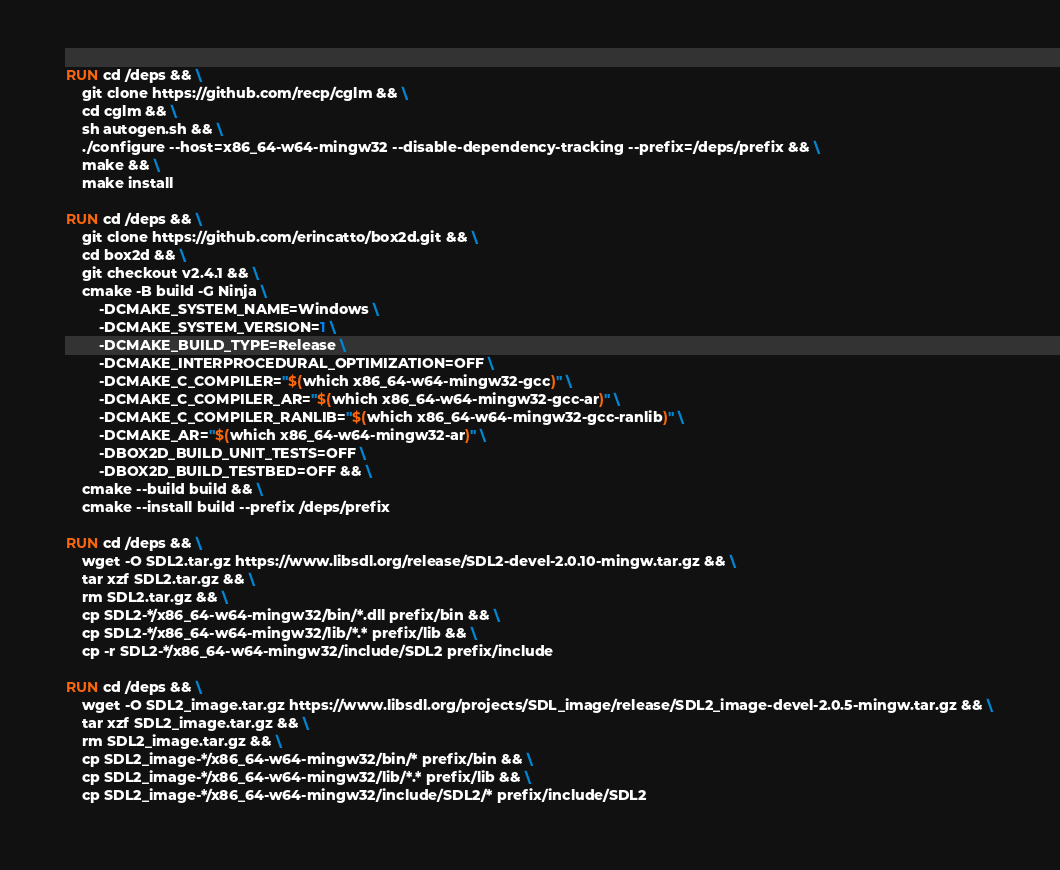<code> <loc_0><loc_0><loc_500><loc_500><_Dockerfile_>RUN cd /deps && \
    git clone https://github.com/recp/cglm && \
    cd cglm && \
    sh autogen.sh && \
    ./configure --host=x86_64-w64-mingw32 --disable-dependency-tracking --prefix=/deps/prefix && \
    make && \
    make install

RUN cd /deps && \
    git clone https://github.com/erincatto/box2d.git && \
    cd box2d && \
    git checkout v2.4.1 && \
    cmake -B build -G Ninja \
        -DCMAKE_SYSTEM_NAME=Windows \
        -DCMAKE_SYSTEM_VERSION=1 \
        -DCMAKE_BUILD_TYPE=Release \
        -DCMAKE_INTERPROCEDURAL_OPTIMIZATION=OFF \
        -DCMAKE_C_COMPILER="$(which x86_64-w64-mingw32-gcc)" \
        -DCMAKE_C_COMPILER_AR="$(which x86_64-w64-mingw32-gcc-ar)" \
        -DCMAKE_C_COMPILER_RANLIB="$(which x86_64-w64-mingw32-gcc-ranlib)" \
        -DCMAKE_AR="$(which x86_64-w64-mingw32-ar)" \
        -DBOX2D_BUILD_UNIT_TESTS=OFF \
        -DBOX2D_BUILD_TESTBED=OFF && \
    cmake --build build && \
    cmake --install build --prefix /deps/prefix

RUN cd /deps && \
    wget -O SDL2.tar.gz https://www.libsdl.org/release/SDL2-devel-2.0.10-mingw.tar.gz && \
    tar xzf SDL2.tar.gz && \
    rm SDL2.tar.gz && \
    cp SDL2-*/x86_64-w64-mingw32/bin/*.dll prefix/bin && \
    cp SDL2-*/x86_64-w64-mingw32/lib/*.* prefix/lib && \
    cp -r SDL2-*/x86_64-w64-mingw32/include/SDL2 prefix/include

RUN cd /deps && \
    wget -O SDL2_image.tar.gz https://www.libsdl.org/projects/SDL_image/release/SDL2_image-devel-2.0.5-mingw.tar.gz && \
    tar xzf SDL2_image.tar.gz && \
    rm SDL2_image.tar.gz && \
    cp SDL2_image-*/x86_64-w64-mingw32/bin/* prefix/bin && \
    cp SDL2_image-*/x86_64-w64-mingw32/lib/*.* prefix/lib && \
    cp SDL2_image-*/x86_64-w64-mingw32/include/SDL2/* prefix/include/SDL2
</code> 